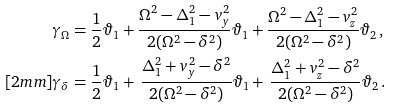Convert formula to latex. <formula><loc_0><loc_0><loc_500><loc_500>\gamma _ { \Omega } & = \frac { 1 } { 2 } \vartheta _ { 1 } + \frac { \Omega ^ { 2 } - \Delta _ { 1 } ^ { 2 } - v _ { y } ^ { 2 } } { 2 ( \Omega ^ { 2 } - \delta ^ { 2 } ) } \vartheta _ { 1 } + \frac { \Omega ^ { 2 } - \Delta _ { 1 } ^ { 2 } - v _ { z } ^ { 2 } } { 2 ( \Omega ^ { 2 } - \delta ^ { 2 } ) } \vartheta _ { 2 } \, , \\ [ 2 m m ] \gamma _ { \delta } & = \frac { 1 } { 2 } \vartheta _ { 1 } + \, \frac { \Delta _ { 1 } ^ { 2 } + v ^ { 2 } _ { y } - \delta ^ { 2 } } { 2 ( \Omega ^ { 2 } - \delta ^ { 2 } ) } \vartheta _ { 1 } + \, \frac { \Delta _ { 1 } ^ { 2 } + v _ { z } ^ { 2 } - \delta ^ { 2 } } { 2 ( \Omega ^ { 2 } - \delta ^ { 2 } ) } \vartheta _ { 2 } \, .</formula> 